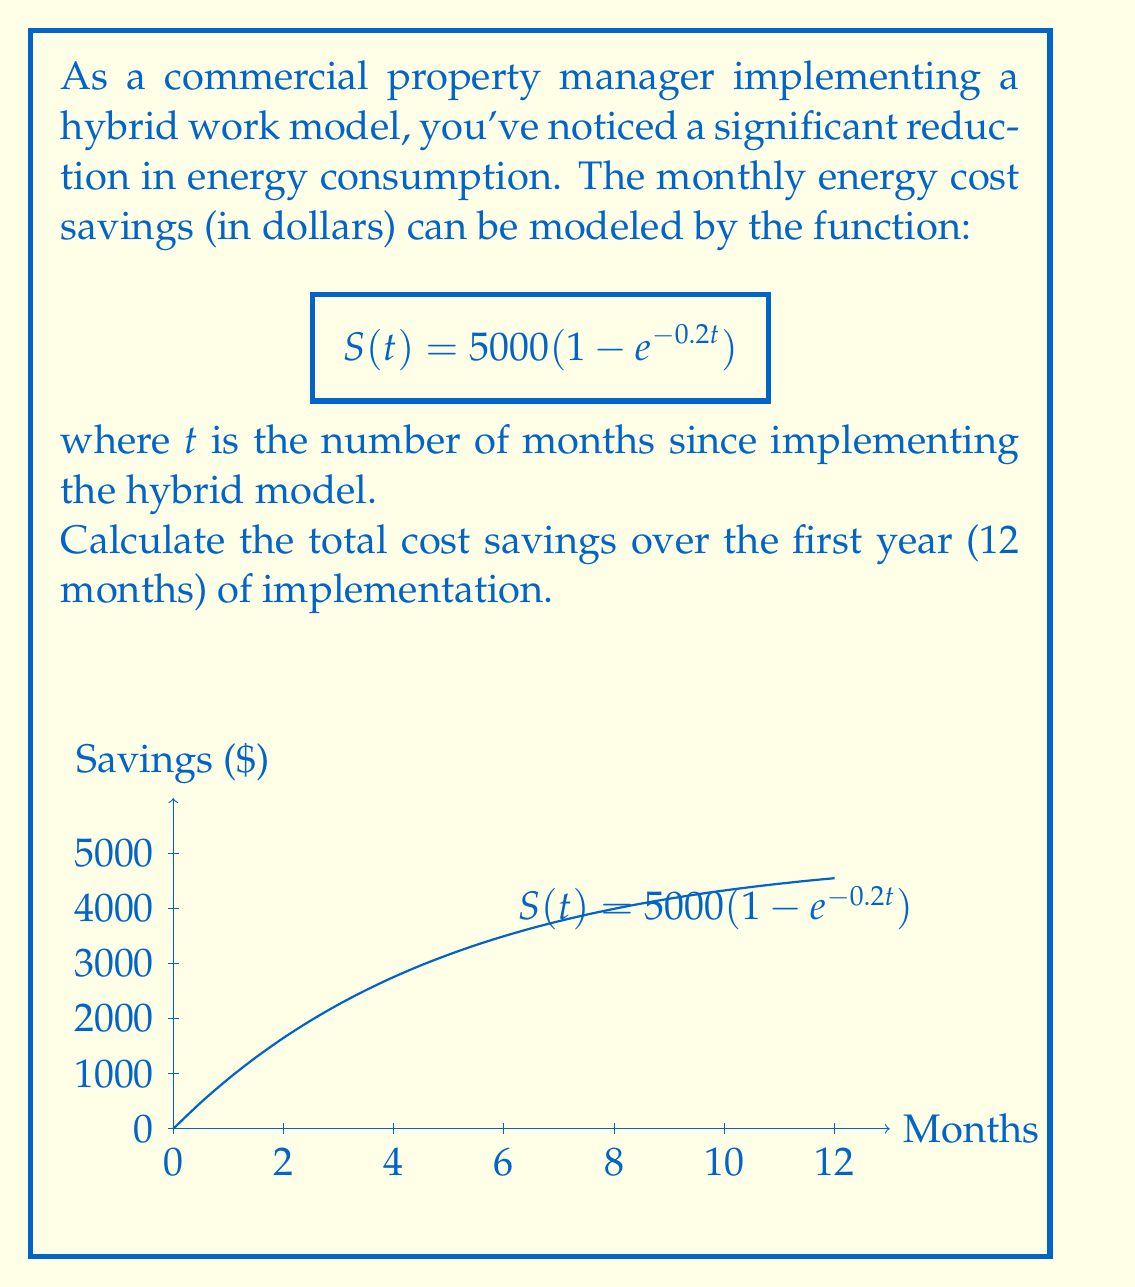Give your solution to this math problem. To solve this problem, we need to follow these steps:

1) The function $S(t) = 5000(1 - e^{-0.2t})$ gives us the savings at any point in time $t$.

2) To find the total savings over 12 months, we need to calculate the area under this curve from $t=0$ to $t=12$.

3) This requires integrating the function from 0 to 12:

   $$\int_0^{12} 5000(1 - e^{-0.2t}) dt$$

4) Let's solve this integral:
   
   $$\begin{align}
   \int_0^{12} 5000(1 - e^{-0.2t}) dt &= 5000\int_0^{12} (1 - e^{-0.2t}) dt \\
   &= 5000[t + 5e^{-0.2t}]_0^{12} \\
   &= 5000[(12 + 5e^{-2.4}) - (0 + 5e^0)] \\
   &= 5000[12 + 5e^{-2.4} - 5] \\
   &= 5000[7 + 5e^{-2.4}]
   \end{align}$$

5) Now, let's calculate this value:
   
   $$5000[7 + 5e^{-2.4}] \approx 35,454.96$$

Therefore, the total cost savings over the first year is approximately $35,454.96.
Answer: $35,454.96 